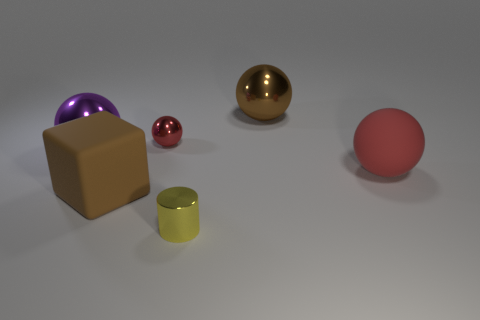Subtract all gray balls. Subtract all gray blocks. How many balls are left? 4 Add 3 purple metal spheres. How many objects exist? 9 Subtract all balls. How many objects are left? 2 Subtract all rubber spheres. Subtract all large metal things. How many objects are left? 3 Add 6 small metal objects. How many small metal objects are left? 8 Add 5 small yellow shiny objects. How many small yellow shiny objects exist? 6 Subtract 0 gray balls. How many objects are left? 6 